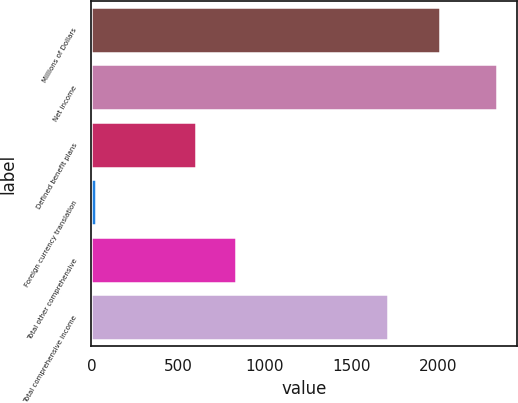<chart> <loc_0><loc_0><loc_500><loc_500><bar_chart><fcel>Millions of Dollars<fcel>Net income<fcel>Defined benefit plans<fcel>Foreign currency translation<fcel>Total other comprehensive<fcel>Total comprehensive income<nl><fcel>2008<fcel>2338<fcel>604<fcel>26<fcel>835.2<fcel>1708<nl></chart> 